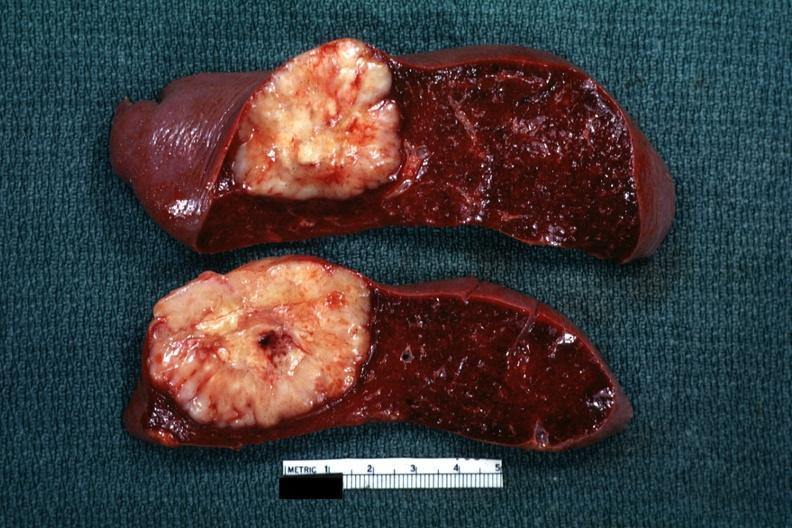does this image show single metastatic appearing lesion is quite large diagnosis was reticulum cell sarcoma?
Answer the question using a single word or phrase. Yes 